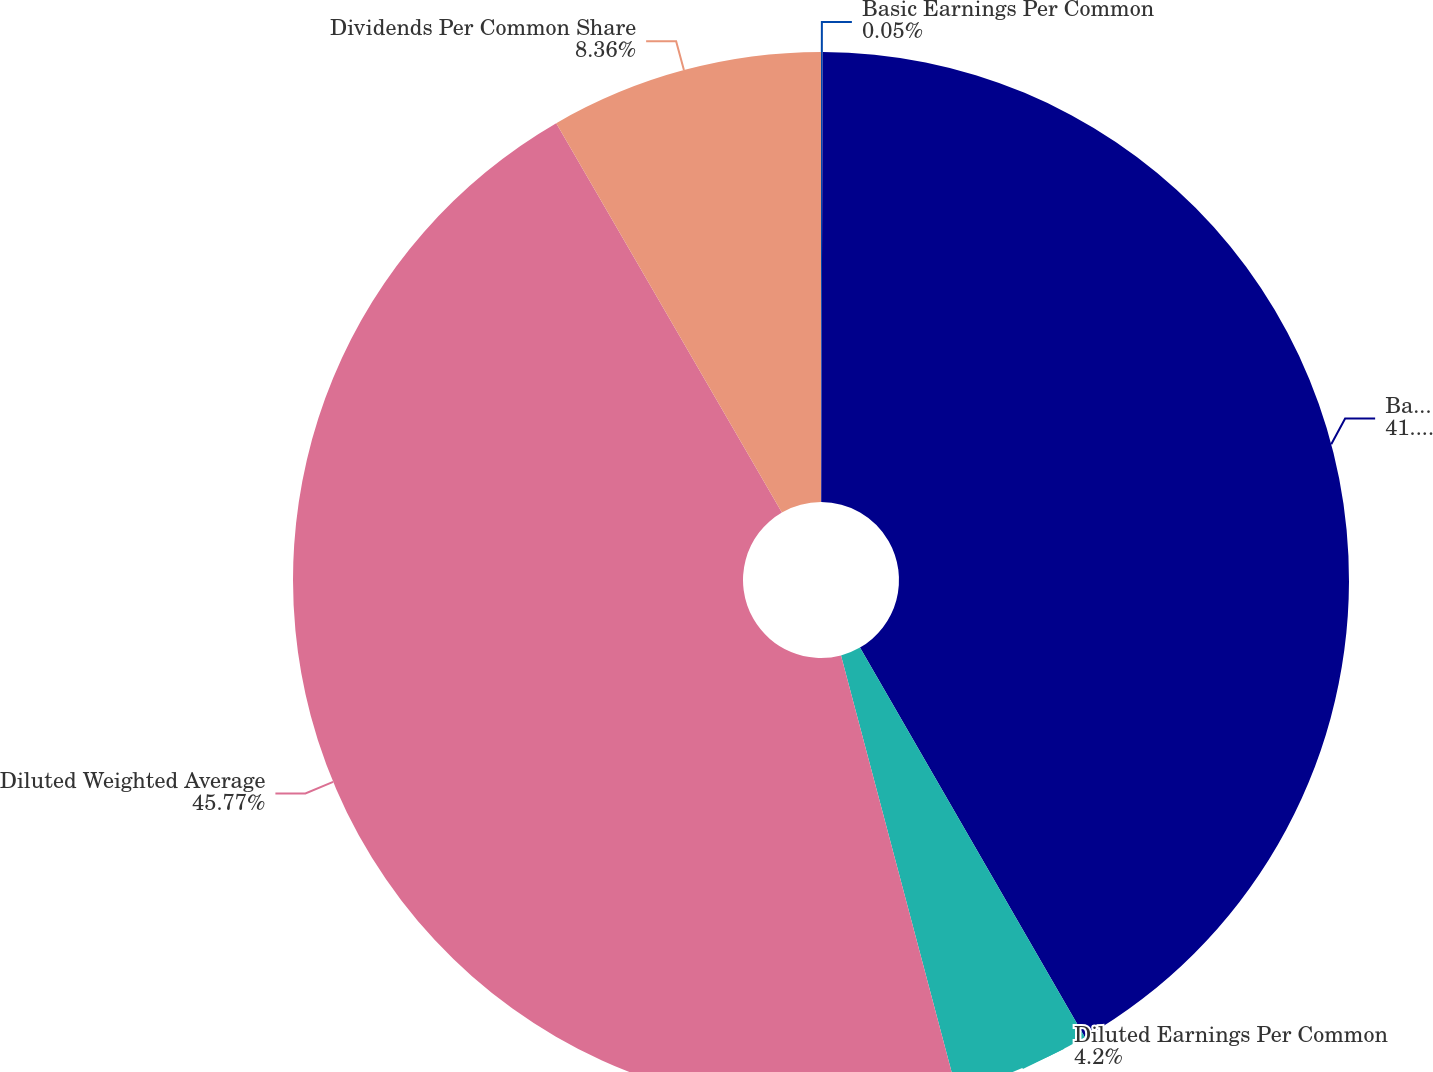Convert chart to OTSL. <chart><loc_0><loc_0><loc_500><loc_500><pie_chart><fcel>Basic Earnings Per Common<fcel>Basic Weighted Average Common<fcel>Diluted Earnings Per Common<fcel>Diluted Weighted Average<fcel>Dividends Per Common Share<nl><fcel>0.05%<fcel>41.62%<fcel>4.2%<fcel>45.77%<fcel>8.36%<nl></chart> 